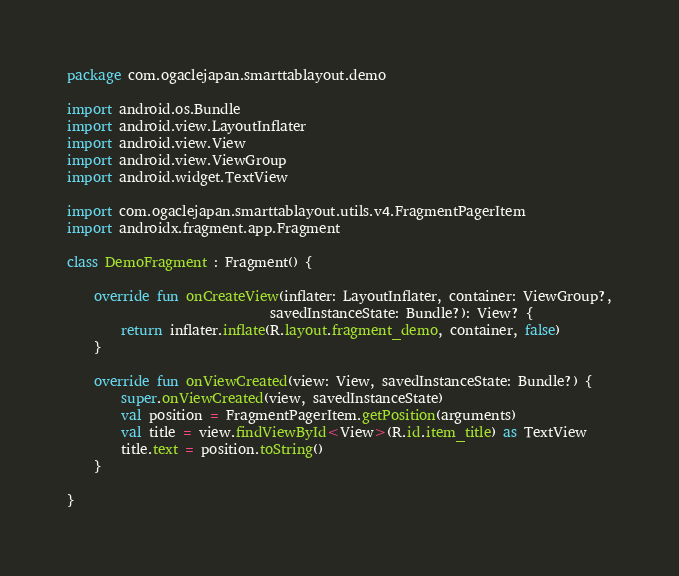<code> <loc_0><loc_0><loc_500><loc_500><_Kotlin_>package com.ogaclejapan.smarttablayout.demo

import android.os.Bundle
import android.view.LayoutInflater
import android.view.View
import android.view.ViewGroup
import android.widget.TextView

import com.ogaclejapan.smarttablayout.utils.v4.FragmentPagerItem
import androidx.fragment.app.Fragment

class DemoFragment : Fragment() {

    override fun onCreateView(inflater: LayoutInflater, container: ViewGroup?,
                              savedInstanceState: Bundle?): View? {
        return inflater.inflate(R.layout.fragment_demo, container, false)
    }

    override fun onViewCreated(view: View, savedInstanceState: Bundle?) {
        super.onViewCreated(view, savedInstanceState)
        val position = FragmentPagerItem.getPosition(arguments)
        val title = view.findViewById<View>(R.id.item_title) as TextView
        title.text = position.toString()
    }

}
</code> 